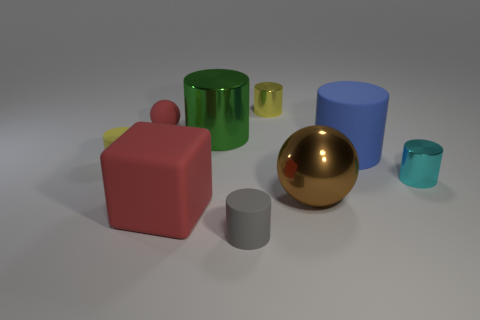Subtract all yellow cylinders. How many cylinders are left? 4 Subtract all blue cylinders. How many cylinders are left? 5 Subtract all blue cylinders. Subtract all red balls. How many cylinders are left? 5 Add 1 large metallic cylinders. How many objects exist? 10 Subtract all blocks. How many objects are left? 8 Subtract all cyan metal things. Subtract all red rubber balls. How many objects are left? 7 Add 2 large blue rubber things. How many large blue rubber things are left? 3 Add 5 gray objects. How many gray objects exist? 6 Subtract 0 purple spheres. How many objects are left? 9 